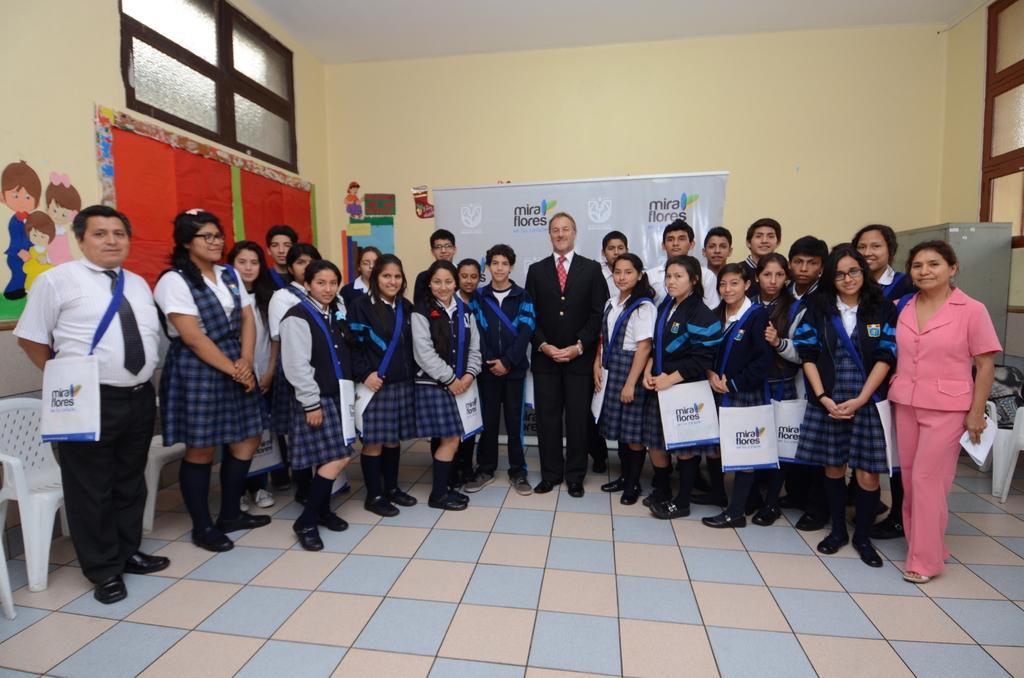How would you summarize this image in a sentence or two? In the picture I can see a group of people standing on the floor. I can see a man in the center and there is a smile on his face. He is wearing a suit and a tie. I can see the wooden chairs on the floor. I can see the glass window on the top left side and the top right side as well. In the background, I can see the banner on the wall. 